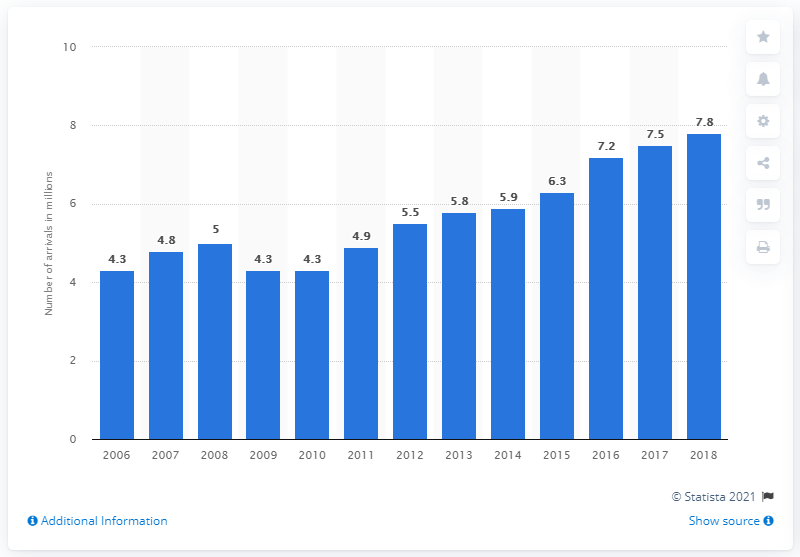Identify some key points in this picture. In 2018, 7,800 tourists arrived in Bulgaria. 